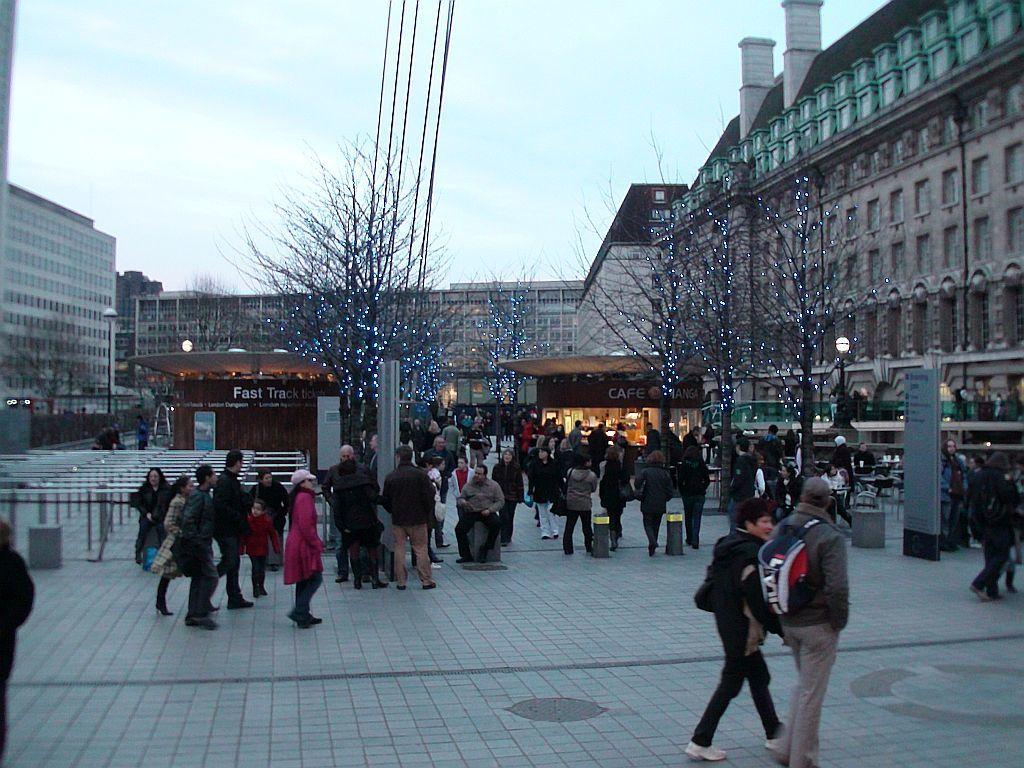What are the people in the image doing? The people in the image are walking on a pavement. What can be seen in the background of the image? There are plants, lights, buildings, and the sky visible in the background of the image. Can you describe the plants in the image? The plants in the image have lights associated with them. What is the general setting of the image? The image is set in an urban environment with buildings in the background. What type of mask is being worn by the plants in the image? There are no masks present in the image; the plants have lights associated with them. 